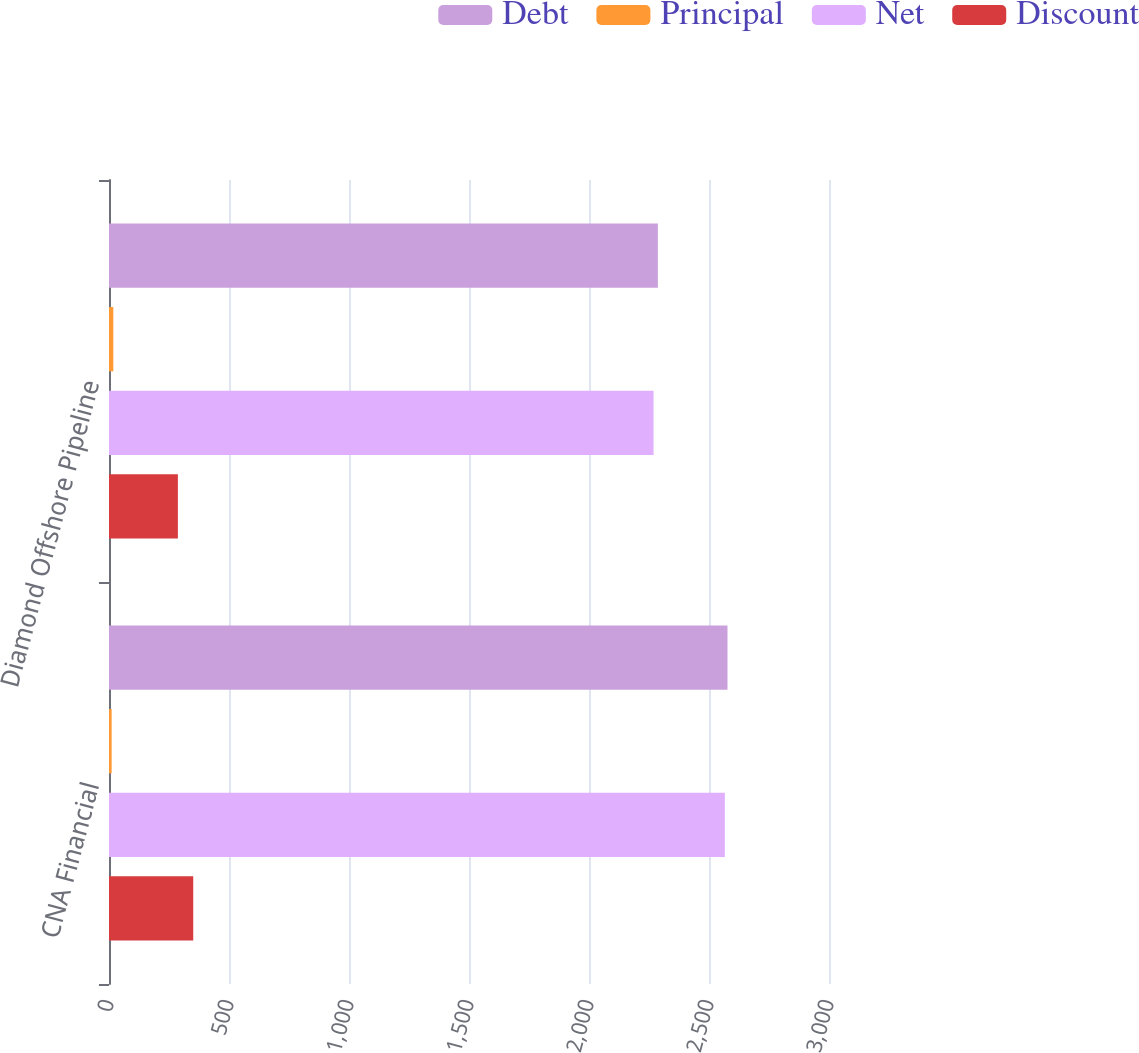Convert chart to OTSL. <chart><loc_0><loc_0><loc_500><loc_500><stacked_bar_chart><ecel><fcel>CNA Financial<fcel>Diamond Offshore Pipeline<nl><fcel>Debt<fcel>2577<fcel>2287<nl><fcel>Principal<fcel>11<fcel>18<nl><fcel>Net<fcel>2566<fcel>2269<nl><fcel>Discount<fcel>351<fcel>287<nl></chart> 